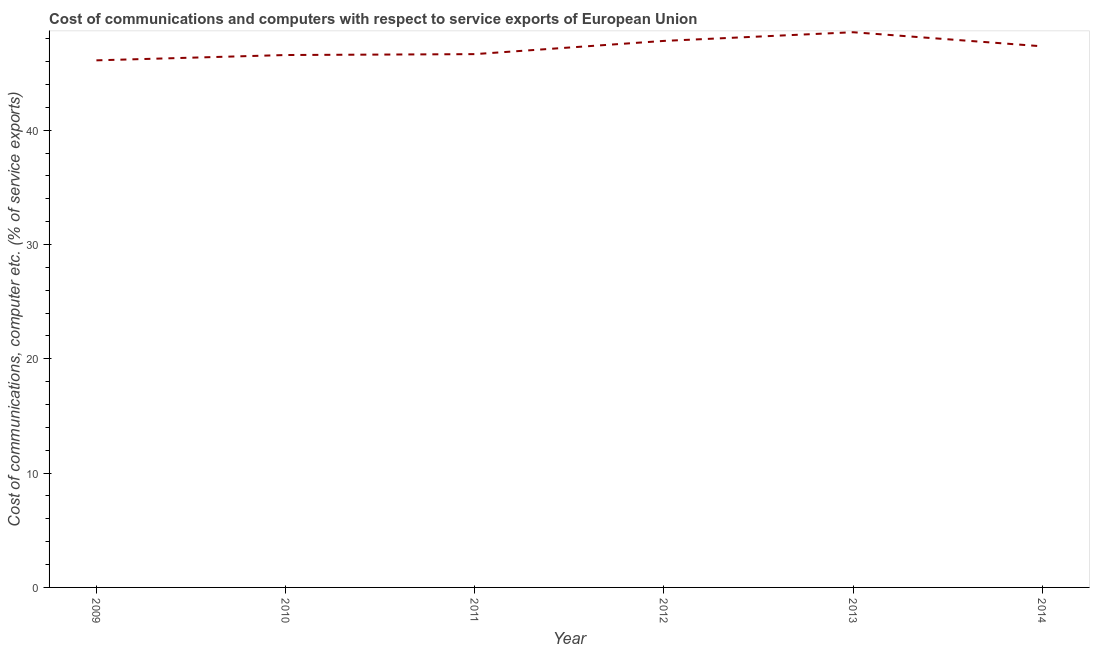What is the cost of communications and computer in 2012?
Provide a succinct answer. 47.81. Across all years, what is the maximum cost of communications and computer?
Provide a short and direct response. 48.57. Across all years, what is the minimum cost of communications and computer?
Make the answer very short. 46.11. In which year was the cost of communications and computer minimum?
Ensure brevity in your answer.  2009. What is the sum of the cost of communications and computer?
Offer a very short reply. 283.04. What is the difference between the cost of communications and computer in 2011 and 2013?
Provide a succinct answer. -1.92. What is the average cost of communications and computer per year?
Offer a terse response. 47.17. What is the median cost of communications and computer?
Provide a succinct answer. 46.99. Do a majority of the years between 2013 and 2011 (inclusive) have cost of communications and computer greater than 2 %?
Give a very brief answer. No. What is the ratio of the cost of communications and computer in 2009 to that in 2013?
Ensure brevity in your answer.  0.95. What is the difference between the highest and the second highest cost of communications and computer?
Your answer should be compact. 0.76. What is the difference between the highest and the lowest cost of communications and computer?
Your response must be concise. 2.46. In how many years, is the cost of communications and computer greater than the average cost of communications and computer taken over all years?
Provide a short and direct response. 3. Does the cost of communications and computer monotonically increase over the years?
Your answer should be compact. No. How many lines are there?
Your answer should be compact. 1. How many years are there in the graph?
Make the answer very short. 6. Are the values on the major ticks of Y-axis written in scientific E-notation?
Make the answer very short. No. Does the graph contain grids?
Provide a short and direct response. No. What is the title of the graph?
Offer a terse response. Cost of communications and computers with respect to service exports of European Union. What is the label or title of the Y-axis?
Offer a terse response. Cost of communications, computer etc. (% of service exports). What is the Cost of communications, computer etc. (% of service exports) in 2009?
Your answer should be very brief. 46.11. What is the Cost of communications, computer etc. (% of service exports) of 2010?
Ensure brevity in your answer.  46.57. What is the Cost of communications, computer etc. (% of service exports) in 2011?
Make the answer very short. 46.65. What is the Cost of communications, computer etc. (% of service exports) of 2012?
Provide a succinct answer. 47.81. What is the Cost of communications, computer etc. (% of service exports) of 2013?
Ensure brevity in your answer.  48.57. What is the Cost of communications, computer etc. (% of service exports) in 2014?
Provide a short and direct response. 47.34. What is the difference between the Cost of communications, computer etc. (% of service exports) in 2009 and 2010?
Your answer should be very brief. -0.46. What is the difference between the Cost of communications, computer etc. (% of service exports) in 2009 and 2011?
Provide a short and direct response. -0.54. What is the difference between the Cost of communications, computer etc. (% of service exports) in 2009 and 2012?
Make the answer very short. -1.7. What is the difference between the Cost of communications, computer etc. (% of service exports) in 2009 and 2013?
Provide a succinct answer. -2.46. What is the difference between the Cost of communications, computer etc. (% of service exports) in 2009 and 2014?
Offer a terse response. -1.23. What is the difference between the Cost of communications, computer etc. (% of service exports) in 2010 and 2011?
Make the answer very short. -0.08. What is the difference between the Cost of communications, computer etc. (% of service exports) in 2010 and 2012?
Ensure brevity in your answer.  -1.24. What is the difference between the Cost of communications, computer etc. (% of service exports) in 2010 and 2013?
Provide a succinct answer. -1.99. What is the difference between the Cost of communications, computer etc. (% of service exports) in 2010 and 2014?
Your answer should be compact. -0.76. What is the difference between the Cost of communications, computer etc. (% of service exports) in 2011 and 2012?
Your response must be concise. -1.16. What is the difference between the Cost of communications, computer etc. (% of service exports) in 2011 and 2013?
Keep it short and to the point. -1.92. What is the difference between the Cost of communications, computer etc. (% of service exports) in 2011 and 2014?
Your answer should be very brief. -0.68. What is the difference between the Cost of communications, computer etc. (% of service exports) in 2012 and 2013?
Your answer should be compact. -0.76. What is the difference between the Cost of communications, computer etc. (% of service exports) in 2012 and 2014?
Provide a succinct answer. 0.47. What is the difference between the Cost of communications, computer etc. (% of service exports) in 2013 and 2014?
Your answer should be very brief. 1.23. What is the ratio of the Cost of communications, computer etc. (% of service exports) in 2009 to that in 2010?
Your answer should be compact. 0.99. What is the ratio of the Cost of communications, computer etc. (% of service exports) in 2009 to that in 2012?
Your response must be concise. 0.96. What is the ratio of the Cost of communications, computer etc. (% of service exports) in 2009 to that in 2013?
Your answer should be compact. 0.95. What is the ratio of the Cost of communications, computer etc. (% of service exports) in 2010 to that in 2012?
Make the answer very short. 0.97. What is the ratio of the Cost of communications, computer etc. (% of service exports) in 2010 to that in 2013?
Offer a terse response. 0.96. What is the ratio of the Cost of communications, computer etc. (% of service exports) in 2010 to that in 2014?
Your answer should be very brief. 0.98. What is the ratio of the Cost of communications, computer etc. (% of service exports) in 2011 to that in 2012?
Your answer should be compact. 0.98. What is the ratio of the Cost of communications, computer etc. (% of service exports) in 2011 to that in 2013?
Your response must be concise. 0.96. What is the ratio of the Cost of communications, computer etc. (% of service exports) in 2011 to that in 2014?
Provide a short and direct response. 0.99. What is the ratio of the Cost of communications, computer etc. (% of service exports) in 2013 to that in 2014?
Provide a short and direct response. 1.03. 